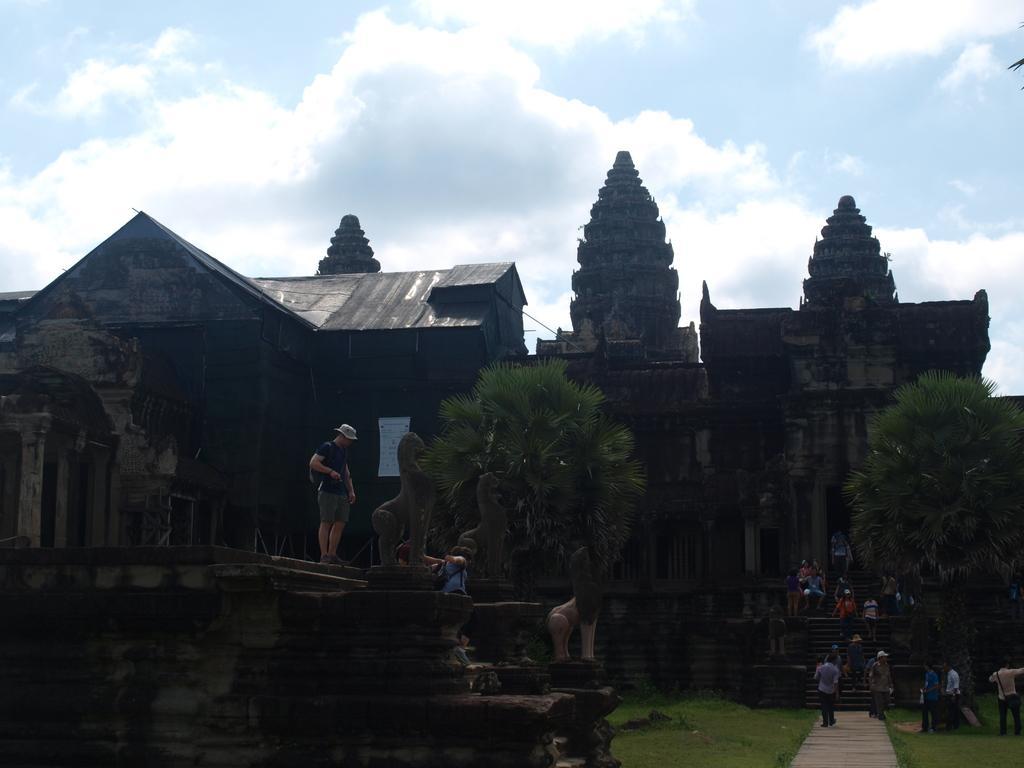Can you describe this image briefly? In this image, we can see trees, there are some buildings, we can see some stars, there are some people walking, at the top there is a sky which is cloudy. 